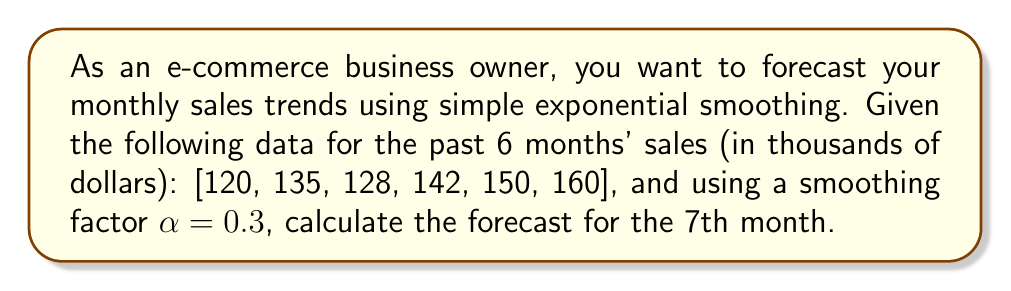Can you solve this math problem? To forecast monthly sales trends using simple exponential smoothing, we use the following formula:

$$F_{t+1} = \alpha Y_t + (1-\alpha)F_t$$

Where:
$F_{t+1}$ is the forecast for the next period
$\alpha$ is the smoothing factor (0 < $\alpha$ < 1)
$Y_t$ is the actual value for the current period
$F_t$ is the forecast for the current period

Steps to solve:

1. Initialize the forecast:
   We typically use the first actual value as the initial forecast.
   $F_1 = Y_1 = 120$

2. Calculate subsequent forecasts:
   $F_2 = \alpha Y_1 + (1-\alpha)F_1 = 0.3(120) + 0.7(120) = 120$
   $F_3 = \alpha Y_2 + (1-\alpha)F_2 = 0.3(135) + 0.7(120) = 124.5$
   $F_4 = \alpha Y_3 + (1-\alpha)F_3 = 0.3(128) + 0.7(124.5) = 125.55$
   $F_5 = \alpha Y_4 + (1-\alpha)F_4 = 0.3(142) + 0.7(125.55) = 130.485$
   $F_6 = \alpha Y_5 + (1-\alpha)F_5 = 0.3(150) + 0.7(130.485) = 136.3395$

3. Calculate the forecast for the 7th month:
   $F_7 = \alpha Y_6 + (1-\alpha)F_6 = 0.3(160) + 0.7(136.3395) = 143.43765$

Therefore, the forecast for the 7th month is approximately 143.44 thousand dollars.
Answer: $143.44 thousand dollars 